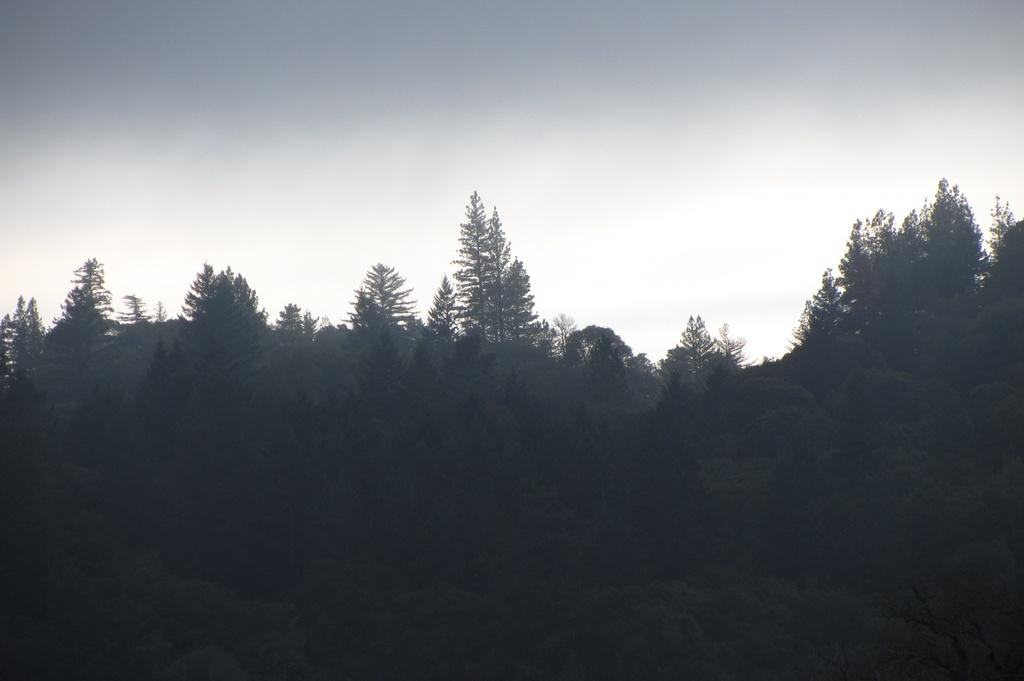What type of vegetation is present at the bottom of the image? There are trees at the bottom of the image. What can be seen at the top of the image? There is a sky at the top of the image. What time is displayed on the watch in the image? There is no watch present in the image. What type of game is being played in the image? There is no game or play activity depicted in the image. 